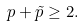<formula> <loc_0><loc_0><loc_500><loc_500>p + \tilde { p } \geq 2 .</formula> 